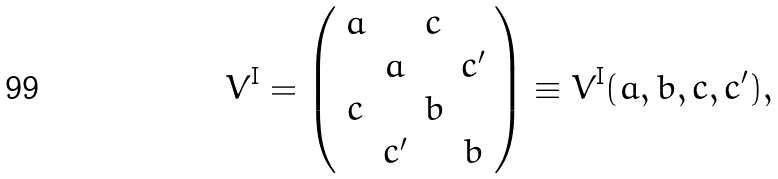<formula> <loc_0><loc_0><loc_500><loc_500>V ^ { \text {I} } = \left ( \begin{array} { c c c c } a & & c & \\ & a & & c ^ { \prime } \\ c & & b & \\ & c ^ { \prime } & & b \end{array} \right ) \equiv V ^ { \text {I} } ( a , b , c , c ^ { \prime } ) ,</formula> 